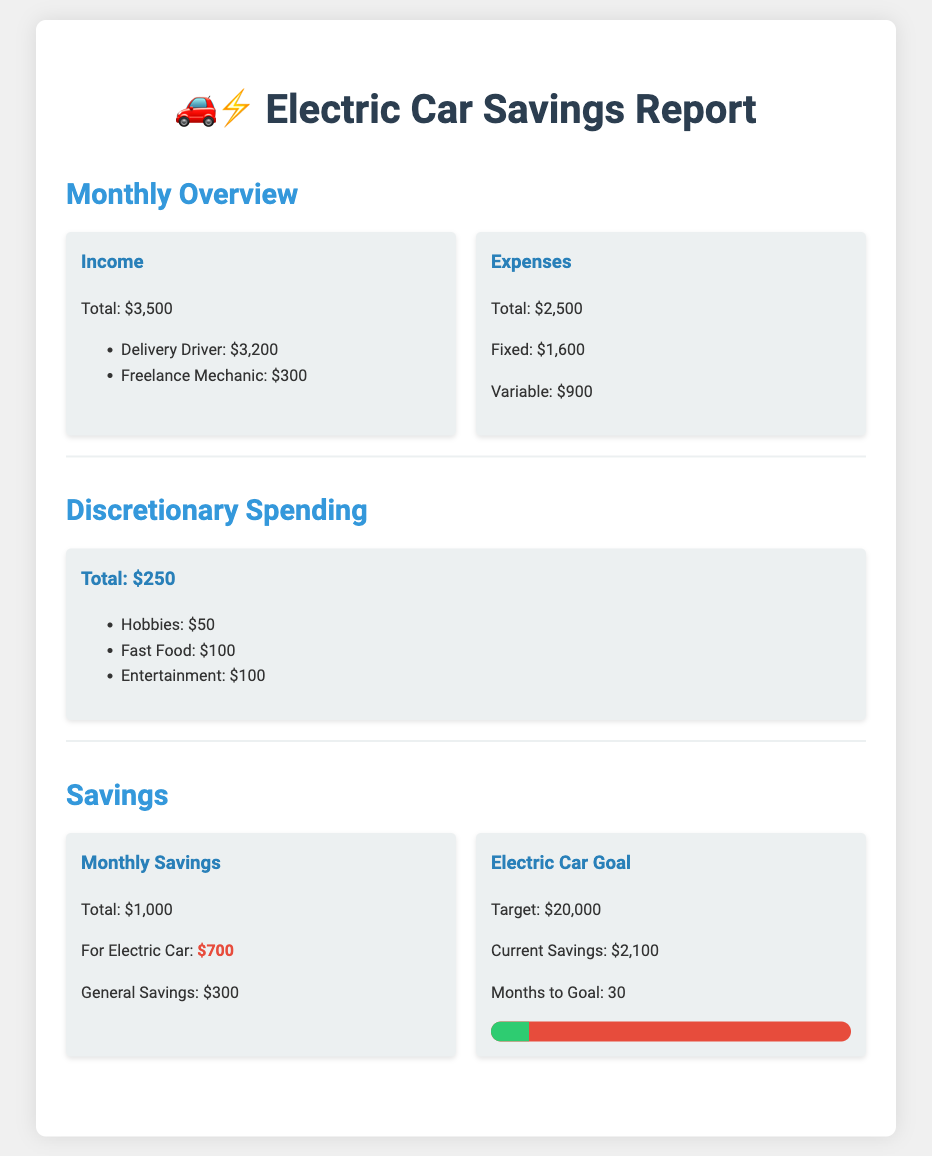What is the total income? The total income is stated in the document as $3,500.
Answer: $3,500 What is the monthly savings allocated for the electric car? The document specifies that $700 is allocated for the electric car from monthly savings.
Answer: $700 What is the target amount for the electric car goal? The document lists the target amount for the electric car as $20,000.
Answer: $20,000 What are the total discretionary spending expenses? The total discretionary spending is detailed in the document as $250.
Answer: $250 How many months until the electric car savings goal is reached? The document states that it will take 30 months to reach the goal.
Answer: 30 What is the total for fixed expenses? Fixed expenses are provided in the document as $1,600.
Answer: $1,600 What are the current savings for the electric car? The current savings towards the electric car is indicated as $2,100 in the document.
Answer: $2,100 What is the composition of the savings allocation? The savings allocation details that $700 is for the electric car and $300 is for general savings.
Answer: $700 for electric car and $300 for general savings 